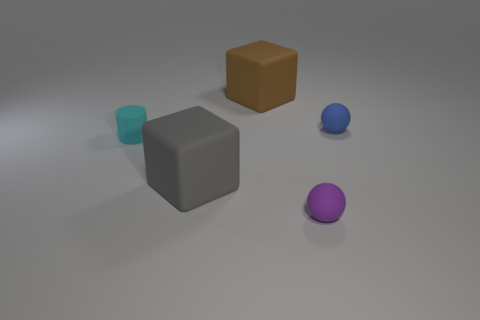How many objects are blue matte balls that are behind the purple rubber sphere or matte spheres that are right of the small purple rubber ball?
Make the answer very short. 1. There is a object that is in front of the big cube that is in front of the tiny blue ball; what size is it?
Provide a succinct answer. Small. How big is the cyan cylinder?
Ensure brevity in your answer.  Small. Is there a yellow cylinder?
Give a very brief answer. No. Are there fewer cyan cylinders than large objects?
Provide a succinct answer. Yes. The large thing that is made of the same material as the gray block is what color?
Make the answer very short. Brown. Does the blue matte object have the same size as the brown thing?
Your answer should be very brief. No. Is there another matte cube that has the same size as the brown cube?
Offer a terse response. Yes. Is the number of gray matte objects on the left side of the small blue matte thing the same as the number of rubber blocks in front of the large brown rubber block?
Keep it short and to the point. Yes. Is the number of big red things greater than the number of big gray blocks?
Make the answer very short. No. 